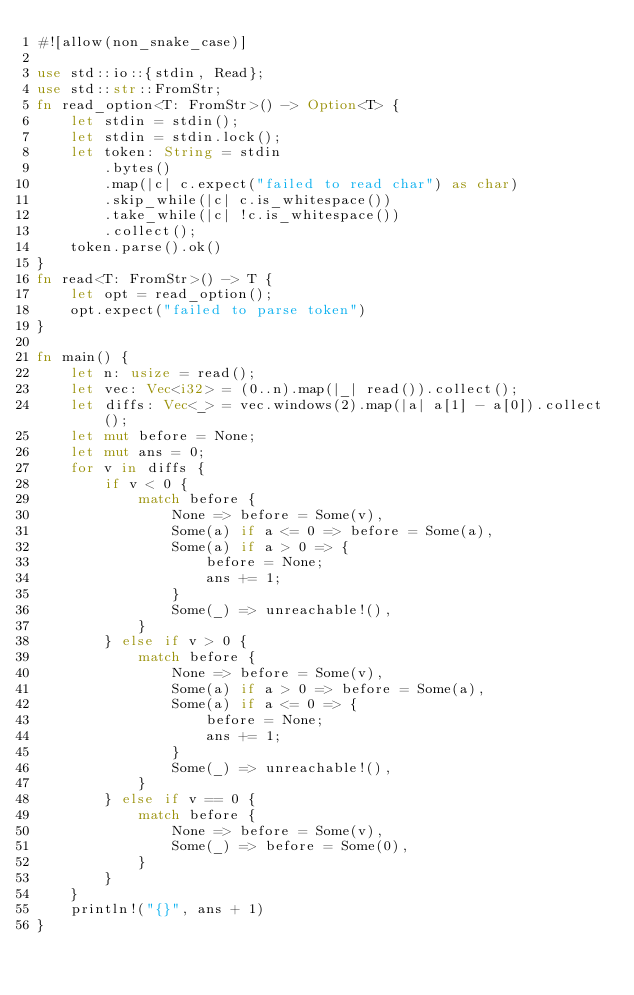<code> <loc_0><loc_0><loc_500><loc_500><_Rust_>#![allow(non_snake_case)]

use std::io::{stdin, Read};
use std::str::FromStr;
fn read_option<T: FromStr>() -> Option<T> {
    let stdin = stdin();
    let stdin = stdin.lock();
    let token: String = stdin
        .bytes()
        .map(|c| c.expect("failed to read char") as char)
        .skip_while(|c| c.is_whitespace())
        .take_while(|c| !c.is_whitespace())
        .collect();
    token.parse().ok()
}
fn read<T: FromStr>() -> T {
    let opt = read_option();
    opt.expect("failed to parse token")
}

fn main() {
    let n: usize = read();
    let vec: Vec<i32> = (0..n).map(|_| read()).collect();
    let diffs: Vec<_> = vec.windows(2).map(|a| a[1] - a[0]).collect();
    let mut before = None;
    let mut ans = 0;
    for v in diffs {
        if v < 0 {
            match before {
                None => before = Some(v),
                Some(a) if a <= 0 => before = Some(a),
                Some(a) if a > 0 => {
                    before = None;
                    ans += 1;
                }
                Some(_) => unreachable!(),
            }
        } else if v > 0 {
            match before {
                None => before = Some(v),
                Some(a) if a > 0 => before = Some(a),
                Some(a) if a <= 0 => {
                    before = None;
                    ans += 1;
                }
                Some(_) => unreachable!(),
            }
        } else if v == 0 {
            match before {
                None => before = Some(v),
                Some(_) => before = Some(0),
            }
        }
    }
    println!("{}", ans + 1)
}
</code> 